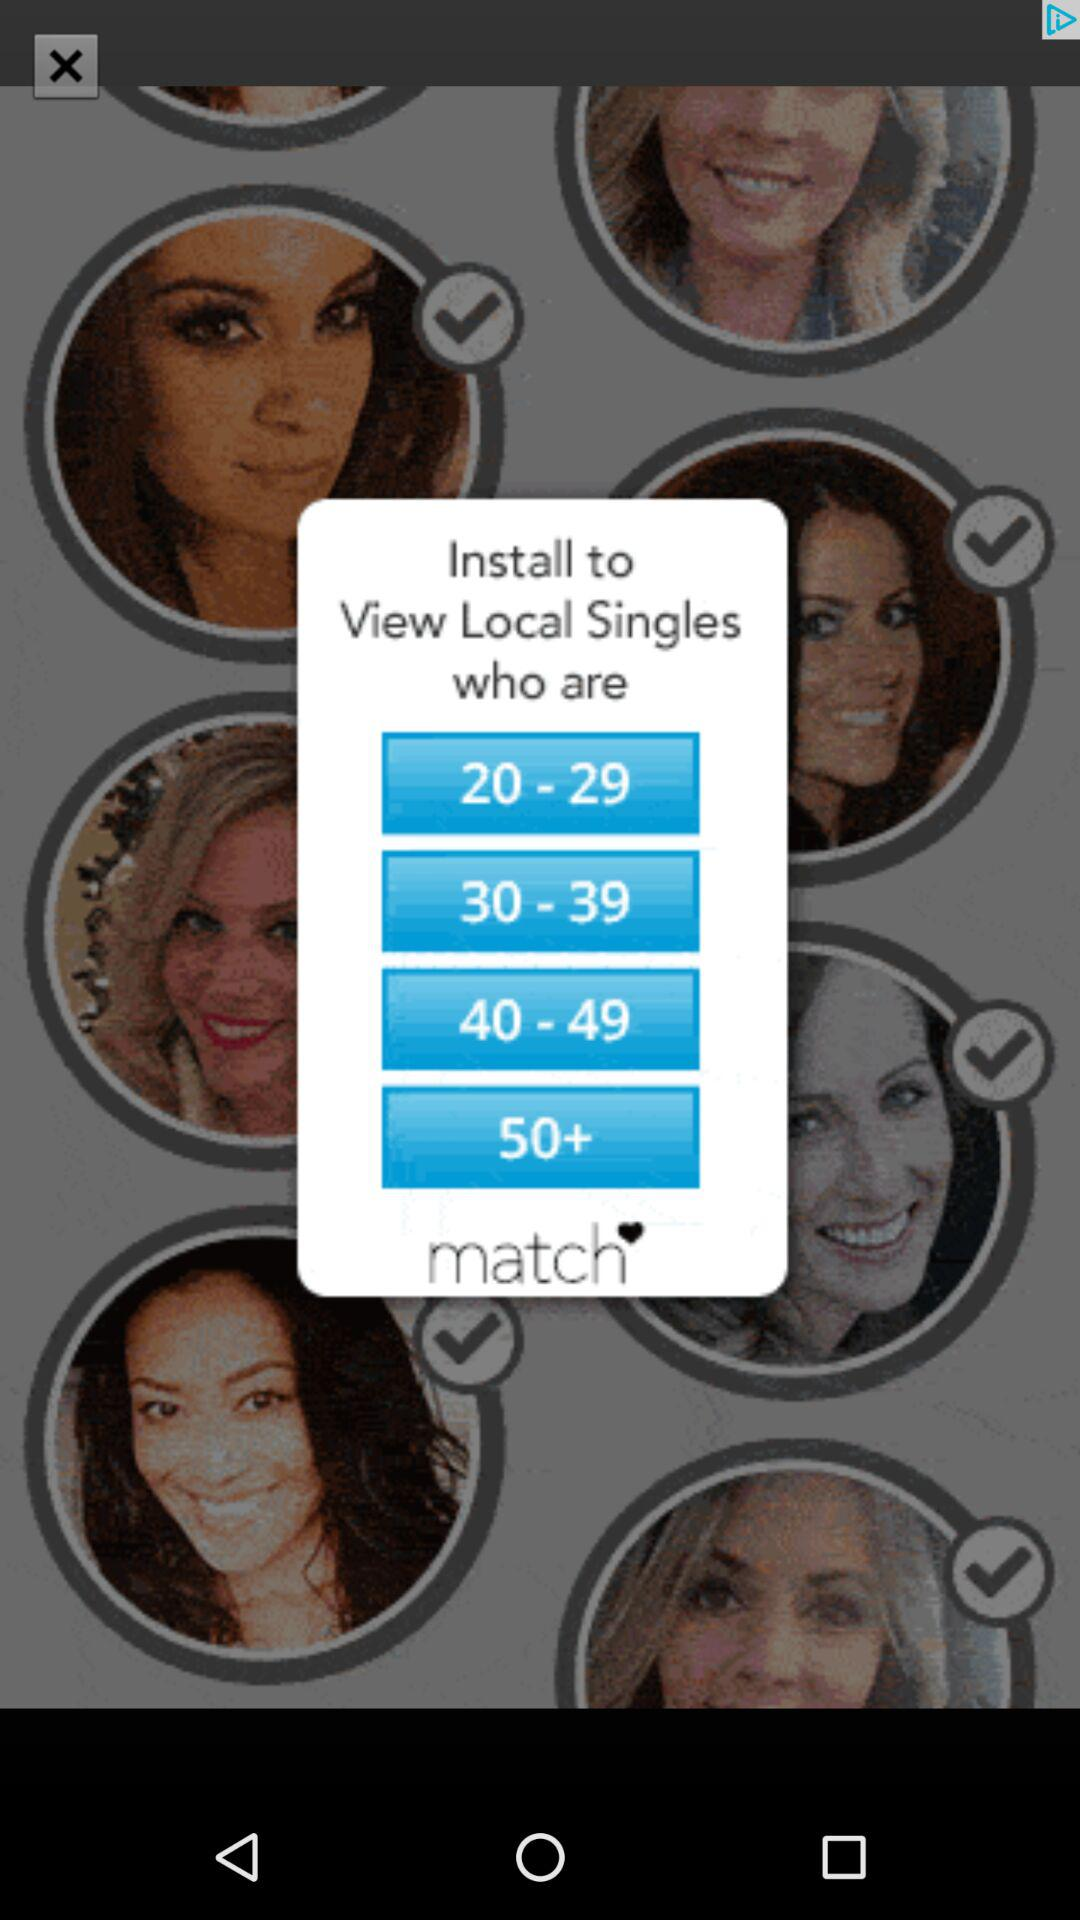How many age ranges are available for the user to select?
Answer the question using a single word or phrase. 4 